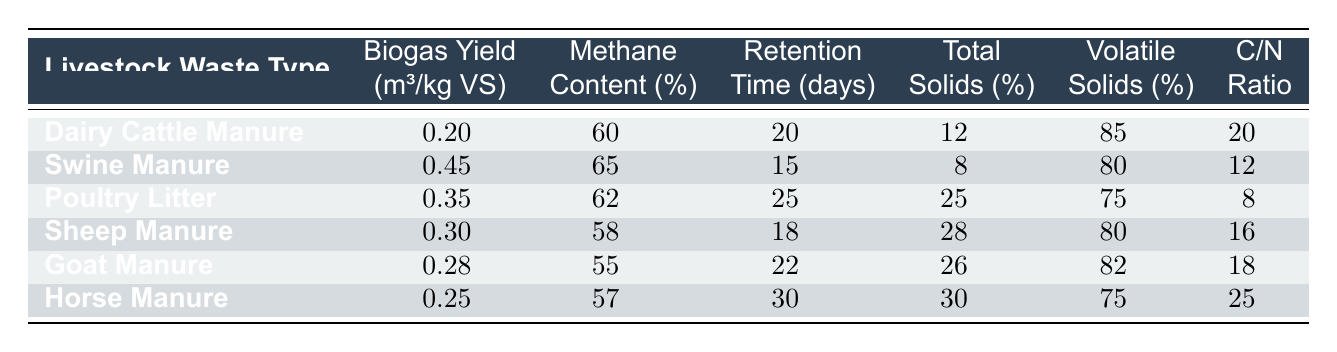What is the biogas yield of Swine Manure? According to the table, Swine Manure has a biogas yield of 0.45 m³/kg VS.
Answer: 0.45 m³/kg VS Which livestock waste type has the highest methane content? The highest methane content in the table is 65%, which corresponds to Swine Manure.
Answer: Swine Manure What is the average retention time for all waste types listed? The retention times are 20, 15, 25, 18, 22, and 30 days, totaling 130 days. Dividing by 6 (the number of types) gives an average of 130/6 ≈ 21.67 days.
Answer: 21.67 days Does Sheep Manure have a higher volatile solids percentage than Goat Manure? Sheep Manure has 80% volatile solids, while Goat Manure has 82%, so Sheep Manure does not have a higher percentage.
Answer: No Which waste type has the lowest C/N ratio? By examining the C/N ratios, Poultry Litter has the lowest C/N ratio at 8.
Answer: 8 If we combine the biogas yields of Dairy Cattle Manure and Horse Manure, what is the total yield? The biogas yields for Dairy Cattle Manure and Horse Manure are 0.20 and 0.25 m³/kg VS, respectively. Adding these gives a total yield of 0.20 + 0.25 = 0.45 m³/kg VS.
Answer: 0.45 m³/kg VS Is the total solids percentage in Goat Manure lower than that in Swine Manure? Goat Manure has a total solids percentage of 26%, while Swine Manure has 8%, so Goat Manure is not lower than Swine Manure.
Answer: No What livestock waste type has the longest retention time? Horse Manure has the longest retention time, with a duration of 30 days.
Answer: Horse Manure Which livestock waste type yields more biogas, Poultry Litter or Dairy Cattle Manure? Poultry Litter has a biogas yield of 0.35 m³/kg VS, while Dairy Cattle Manure yields 0.20 m³/kg VS. Poultry Litter yields more biogas.
Answer: Poultry Litter 